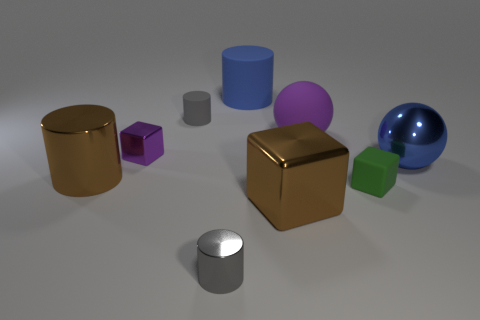Are there any other things that have the same size as the purple cube?
Make the answer very short. Yes. Are there more gray things behind the blue rubber object than large purple cubes?
Your answer should be very brief. No. There is a brown metal object that is behind the green rubber thing; does it have the same shape as the large blue shiny thing?
Your answer should be compact. No. How many brown things are shiny objects or rubber cylinders?
Provide a succinct answer. 2. Is the number of tiny green blocks greater than the number of objects?
Provide a succinct answer. No. The shiny cylinder that is the same size as the brown shiny block is what color?
Provide a short and direct response. Brown. What number of cylinders are large blue things or rubber objects?
Make the answer very short. 2. There is a green object; does it have the same shape as the brown shiny object to the right of the brown metal cylinder?
Your response must be concise. Yes. How many matte cylinders have the same size as the blue metallic object?
Offer a terse response. 1. Is the shape of the large blue thing that is in front of the tiny purple block the same as the tiny gray metallic thing left of the green rubber thing?
Ensure brevity in your answer.  No. 